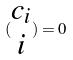Convert formula to latex. <formula><loc_0><loc_0><loc_500><loc_500>( \begin{matrix} c _ { i } \\ i \end{matrix} ) = 0</formula> 